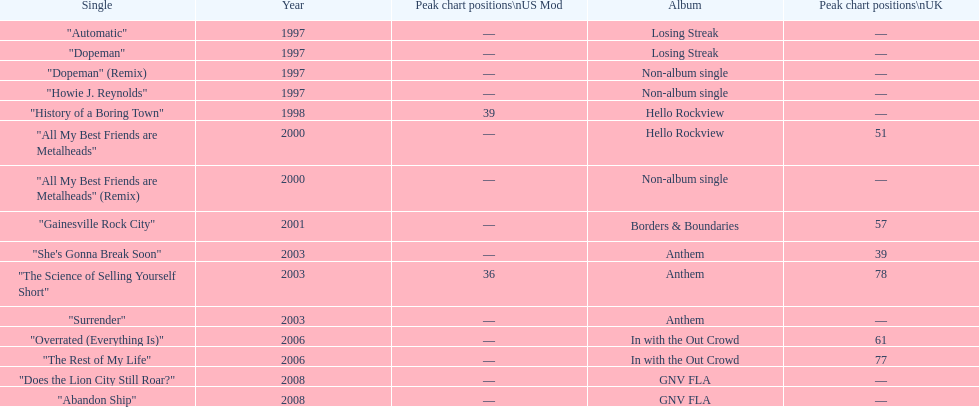What was the average chart position of their singles in the uk? 60.5. 